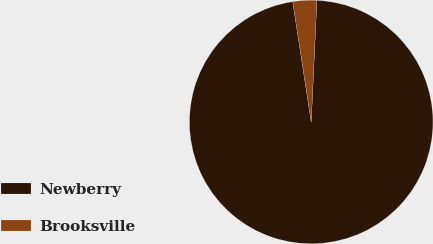Convert chart to OTSL. <chart><loc_0><loc_0><loc_500><loc_500><pie_chart><fcel>Newberry<fcel>Brooksville<nl><fcel>96.83%<fcel>3.17%<nl></chart> 